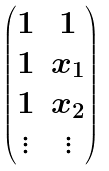Convert formula to latex. <formula><loc_0><loc_0><loc_500><loc_500>\begin{pmatrix} 1 & 1 \\ 1 & x _ { 1 } \\ 1 & x _ { 2 } \\ \vdots & \vdots \end{pmatrix}</formula> 